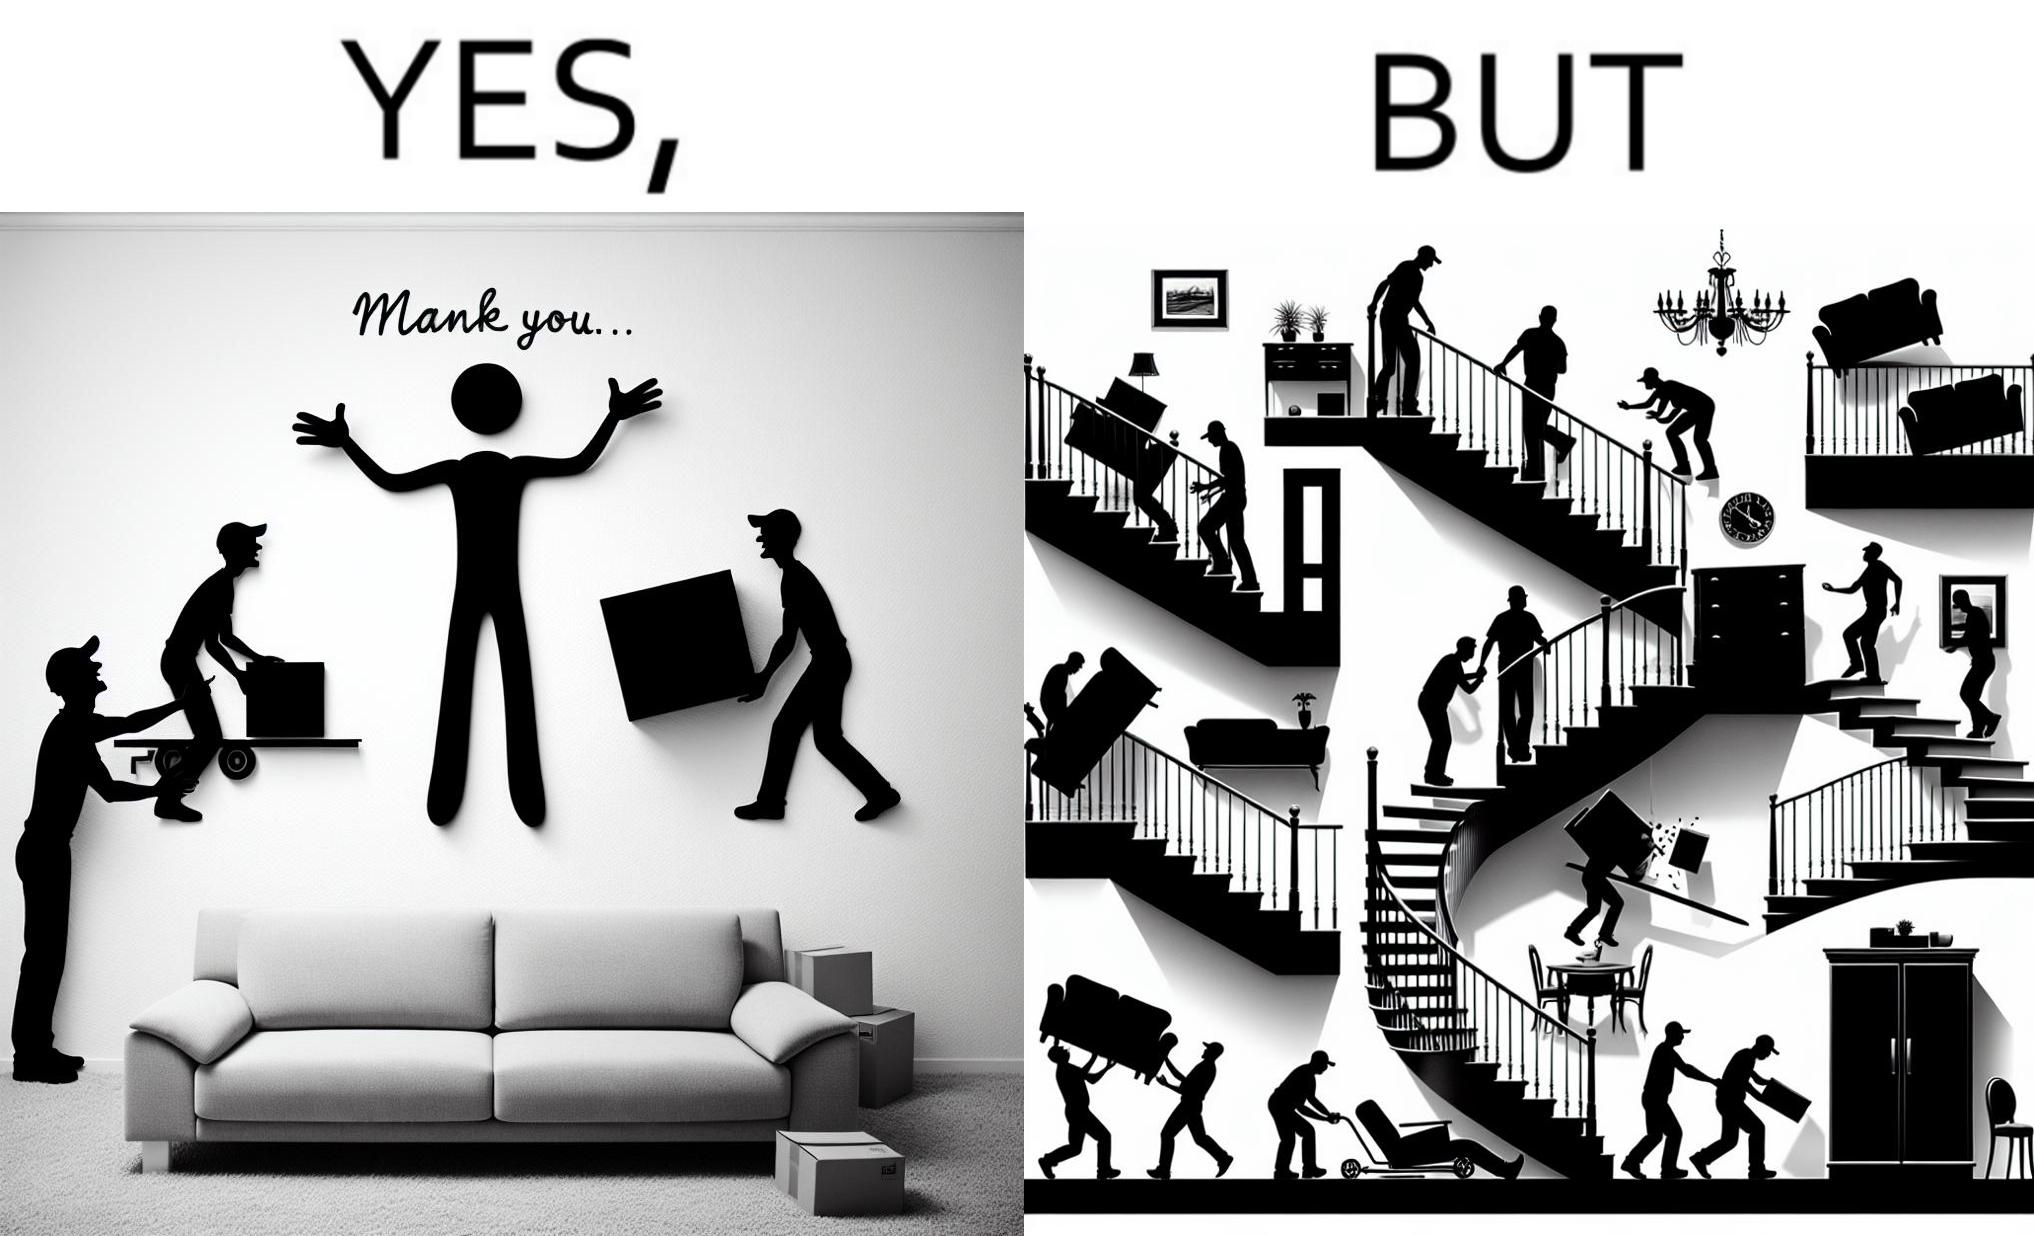Why is this image considered satirical? The images are funny since they show how even though the hired movers achieve their task of moving in furniture, in the process, the cause damage to the whole house 